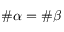Convert formula to latex. <formula><loc_0><loc_0><loc_500><loc_500>\# \alpha = \# \beta</formula> 